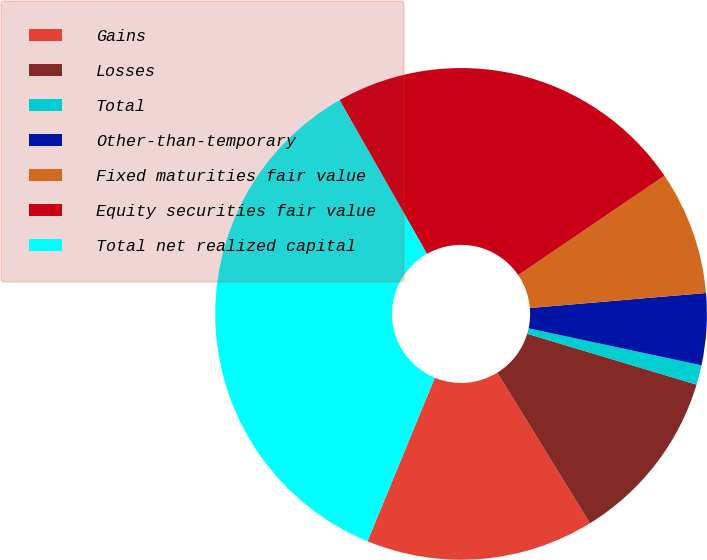Convert chart to OTSL. <chart><loc_0><loc_0><loc_500><loc_500><pie_chart><fcel>Gains<fcel>Losses<fcel>Total<fcel>Other-than-temporary<fcel>Fixed maturities fair value<fcel>Equity securities fair value<fcel>Total net realized capital<nl><fcel>15.0%<fcel>11.57%<fcel>1.29%<fcel>4.71%<fcel>8.14%<fcel>23.73%<fcel>35.56%<nl></chart> 